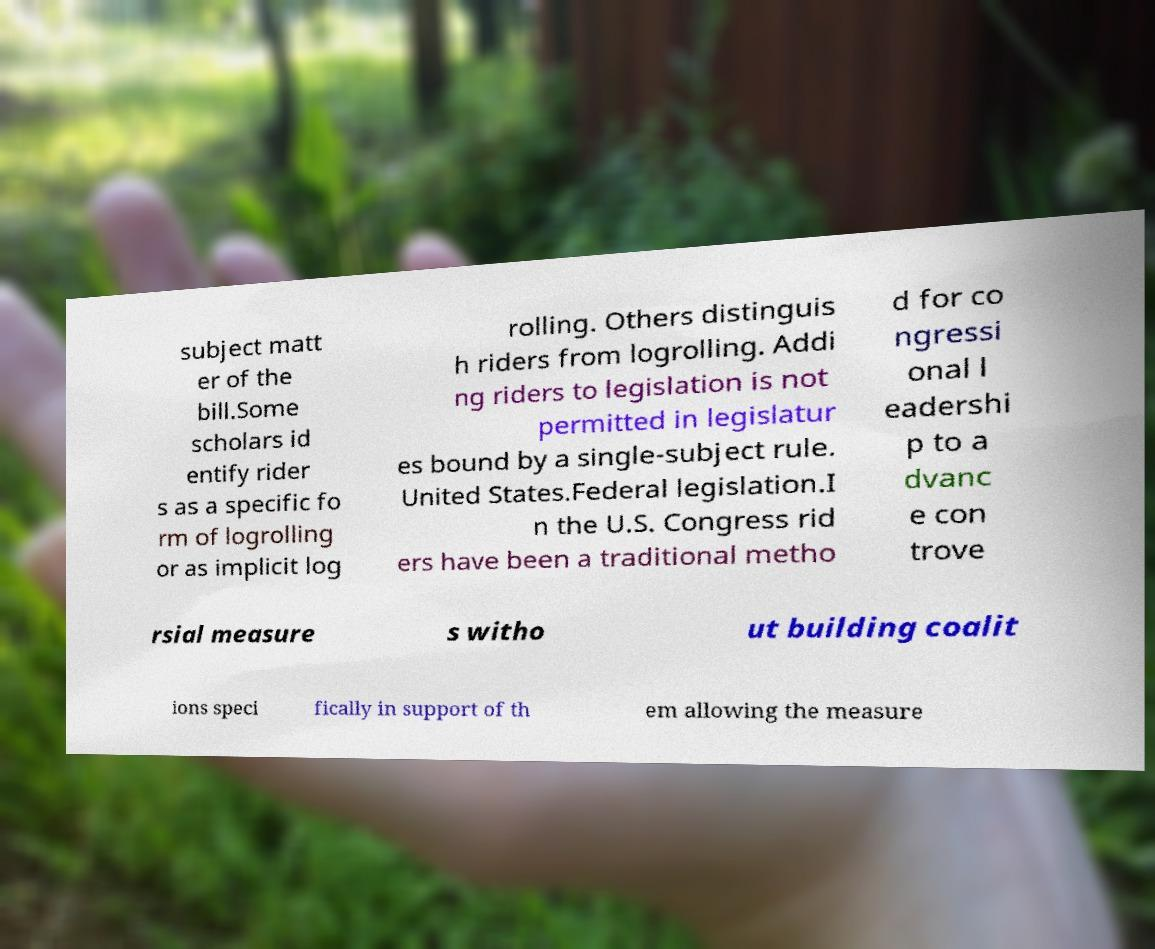What messages or text are displayed in this image? I need them in a readable, typed format. subject matt er of the bill.Some scholars id entify rider s as a specific fo rm of logrolling or as implicit log rolling. Others distinguis h riders from logrolling. Addi ng riders to legislation is not permitted in legislatur es bound by a single-subject rule. United States.Federal legislation.I n the U.S. Congress rid ers have been a traditional metho d for co ngressi onal l eadershi p to a dvanc e con trove rsial measure s witho ut building coalit ions speci fically in support of th em allowing the measure 